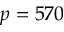Convert formula to latex. <formula><loc_0><loc_0><loc_500><loc_500>p = 5 7 0</formula> 